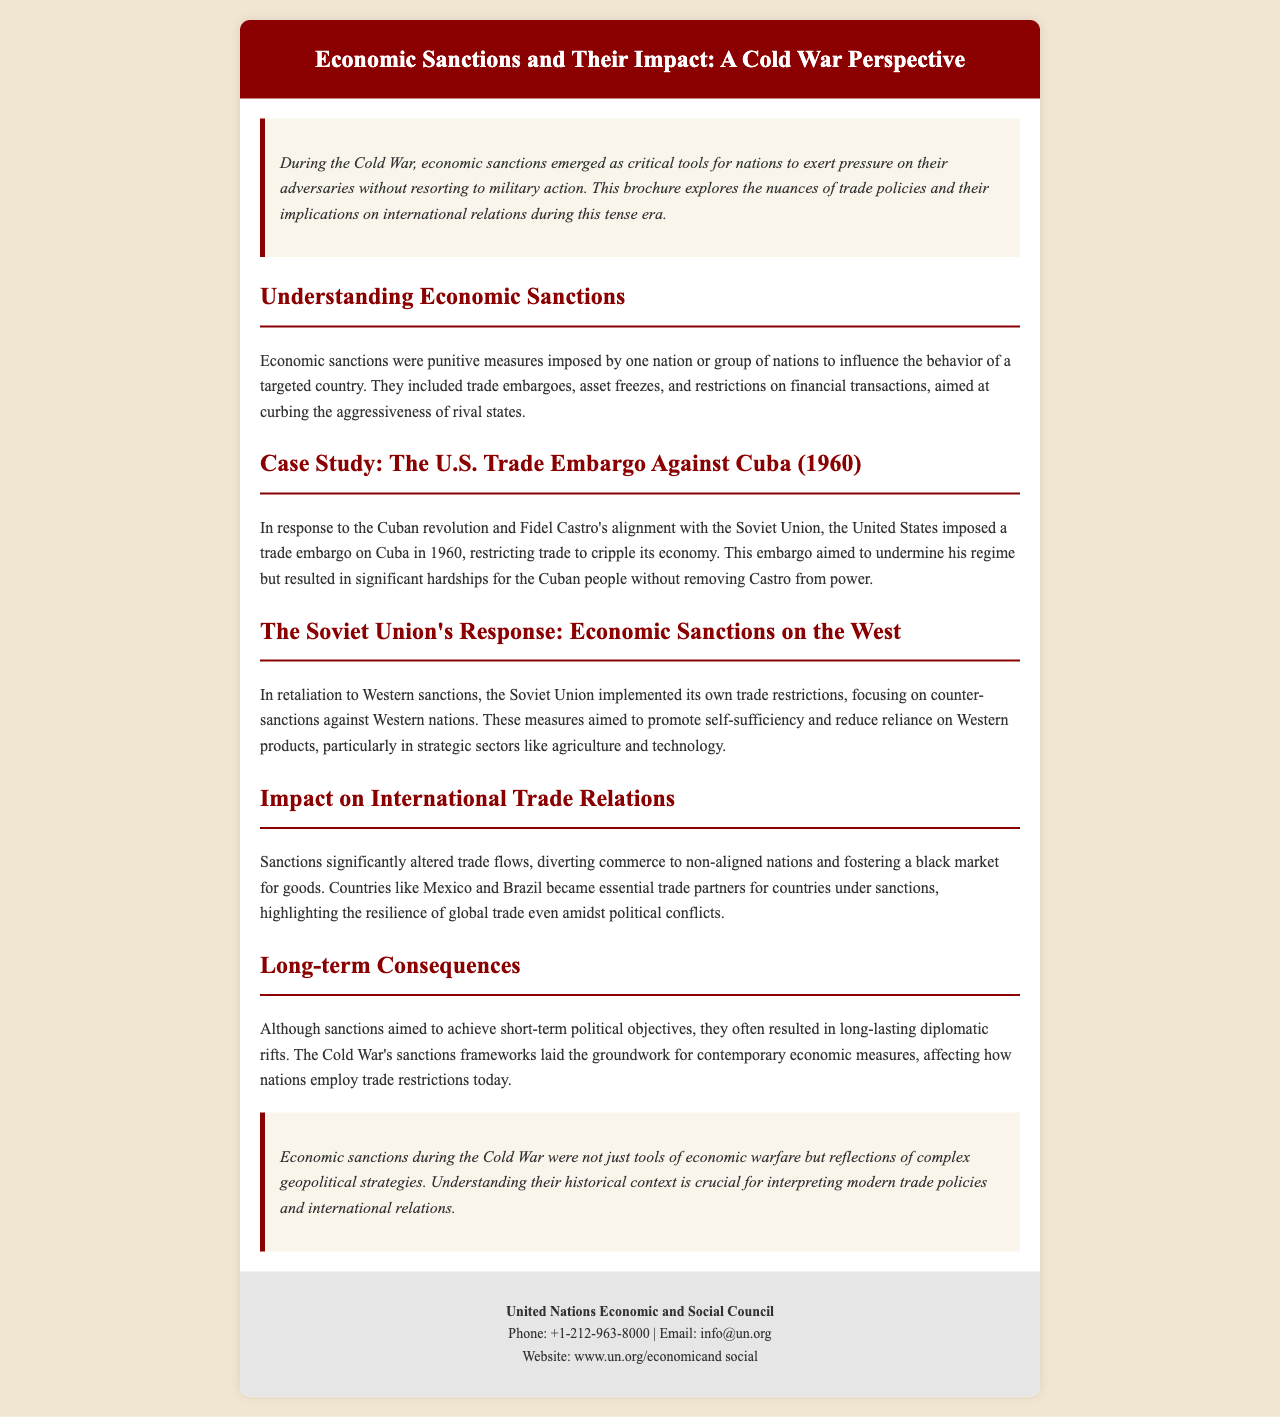What is the title of the brochure? The title of the brochure is provided in the header section of the document, which is "Economic Sanctions and Their Impact: A Cold War Perspective."
Answer: Economic Sanctions and Their Impact: A Cold War Perspective When did the U.S. impose the trade embargo against Cuba? The document specifies the year when the U.S. trade embargo was imposed, which is 1960.
Answer: 1960 What major country did Fidel Castro align with? The document indicates a specific alignment of Fidel Castro, which was with the Soviet Union.
Answer: Soviet Union What type of sanctions did the Soviet Union implement as a response? The document describes a specific type of measures taken by the Soviet Union, which were trade restrictions.
Answer: Trade restrictions What impact did sanctions have on trade flows? The document mentions a significant effect of sanctions on trade, highlighting diversion to non-aligned nations and fostering a black market.
Answer: Diversion and black market What was a consequence of using economic sanctions during the Cold War? The brochure discusses a lasting outcome resulting from the sanctions, which is diplomatic rifts.
Answer: Diplomatic rifts What were sanctions aimed at curbing? The brochure outlines the intended purpose of economic sanctions, which was to curb the aggressiveness of rival states.
Answer: Aggressiveness of rival states What does the term 'counter-sanctions' refer to in the context of this document? In the document, the term refers to sanctions implemented by the Soviet Union in retaliation to Western sanctions.
Answer: Counter-sanctions What aspect of global trade did countries like Mexico and Brazil represent? The document highlights a key role of these countries in the context of sanctions, emphasizing their importance as trade partners.
Answer: Trade partners 